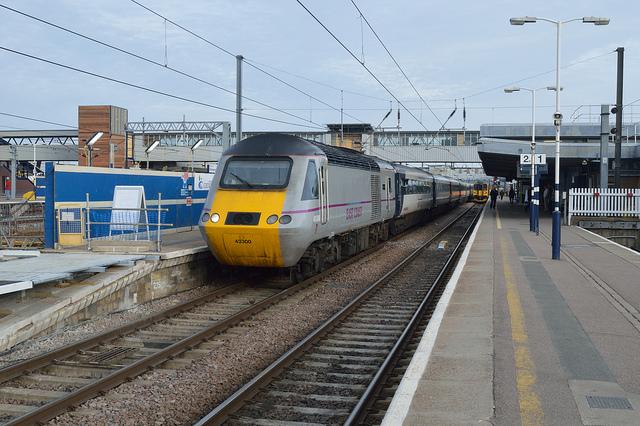Is this train parked or moving?
Answer briefly. Parked. Is this a passenger's train?
Quick response, please. Yes. What is the number on the light post to the right of the train on the platform?
Answer briefly. 21. How many poles are blue?
Write a very short answer. 2. 